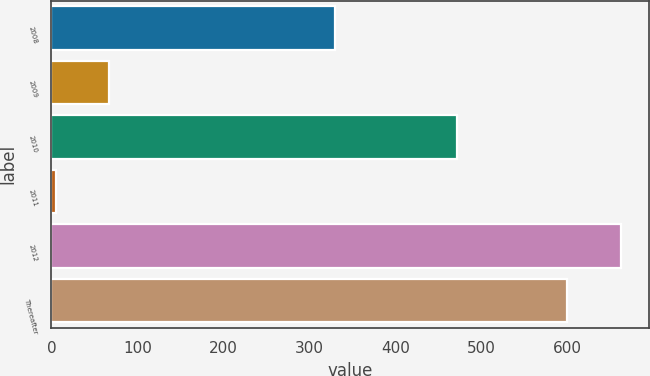<chart> <loc_0><loc_0><loc_500><loc_500><bar_chart><fcel>2008<fcel>2009<fcel>2010<fcel>2011<fcel>2012<fcel>Thereafter<nl><fcel>330<fcel>67.5<fcel>472<fcel>5<fcel>662.5<fcel>600<nl></chart> 